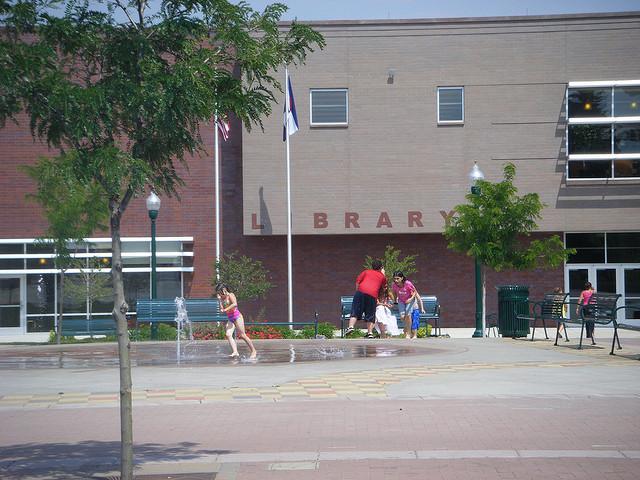What type of building is that?
Quick response, please. Library. Is one of the people wearing a bathing suit?
Short answer required. Yes. Is there a tire in this picture?
Be succinct. No. Is this in color?
Answer briefly. Yes. How many people are in this picture?
Quick response, please. 4. How many trees are visible in the picture?
Be succinct. 5. Will these trees drop their leaves in winter?
Short answer required. Yes. 